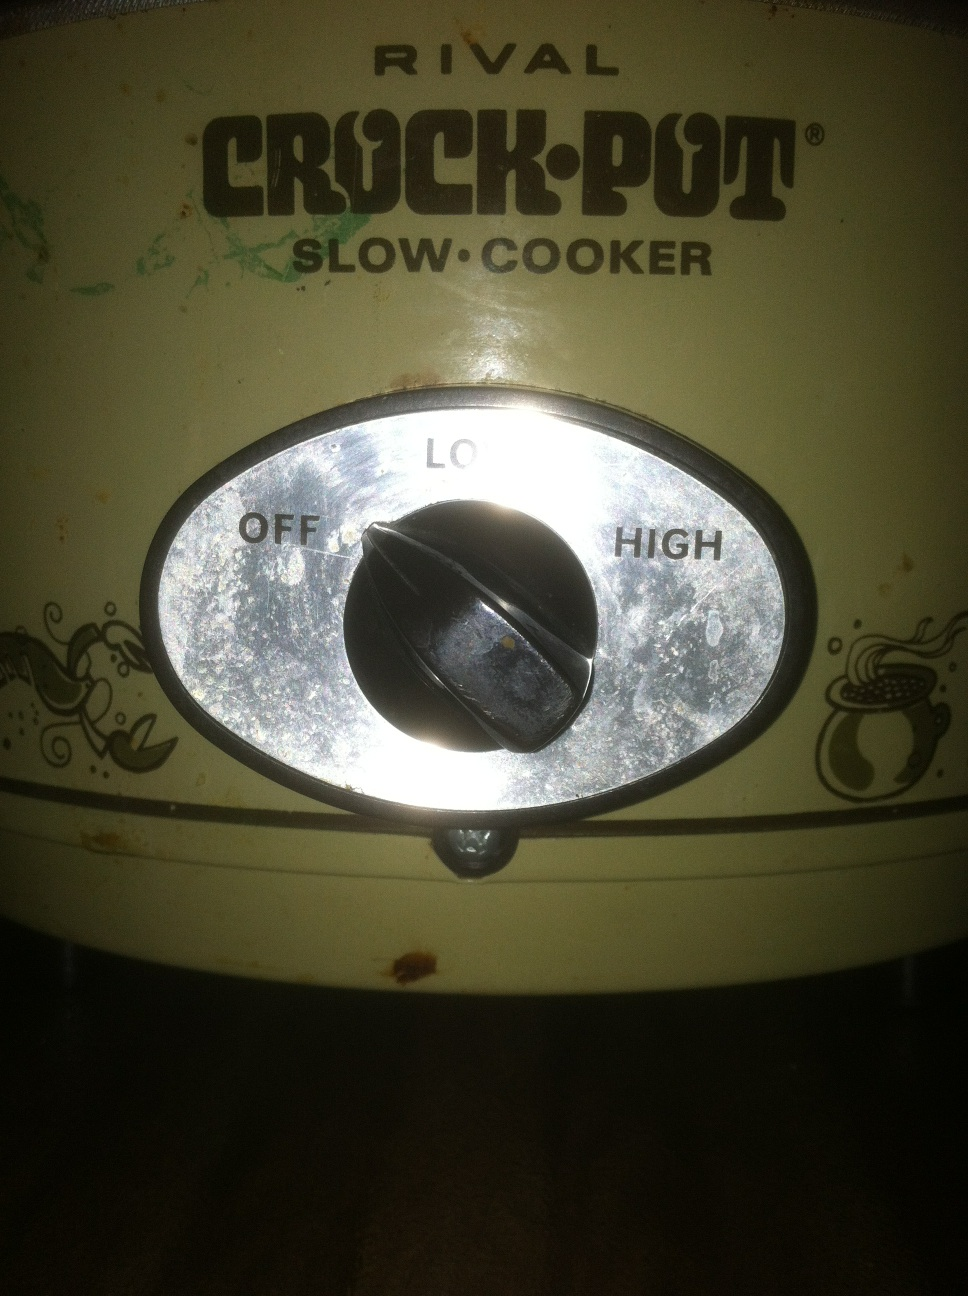Oh. Thank you all my crock pot. The image shows a Rival Crock-Pot Slow Cooker. It looks like it’s set to the 'Off' position. Crock-pots are great for making slow-cooked meals with minimal effort. Do you use it often to prepare your meals? 